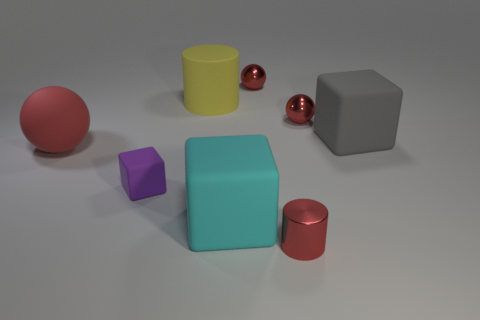Subtract all metal balls. How many balls are left? 1 Subtract all purple blocks. How many blocks are left? 2 Subtract all cubes. How many objects are left? 5 Subtract 2 cubes. How many cubes are left? 1 Subtract all green cylinders. How many yellow spheres are left? 0 Subtract all big yellow cylinders. Subtract all small rubber balls. How many objects are left? 7 Add 6 tiny red objects. How many tiny red objects are left? 9 Add 3 small purple matte things. How many small purple matte things exist? 4 Add 1 big yellow rubber things. How many objects exist? 9 Subtract 3 red spheres. How many objects are left? 5 